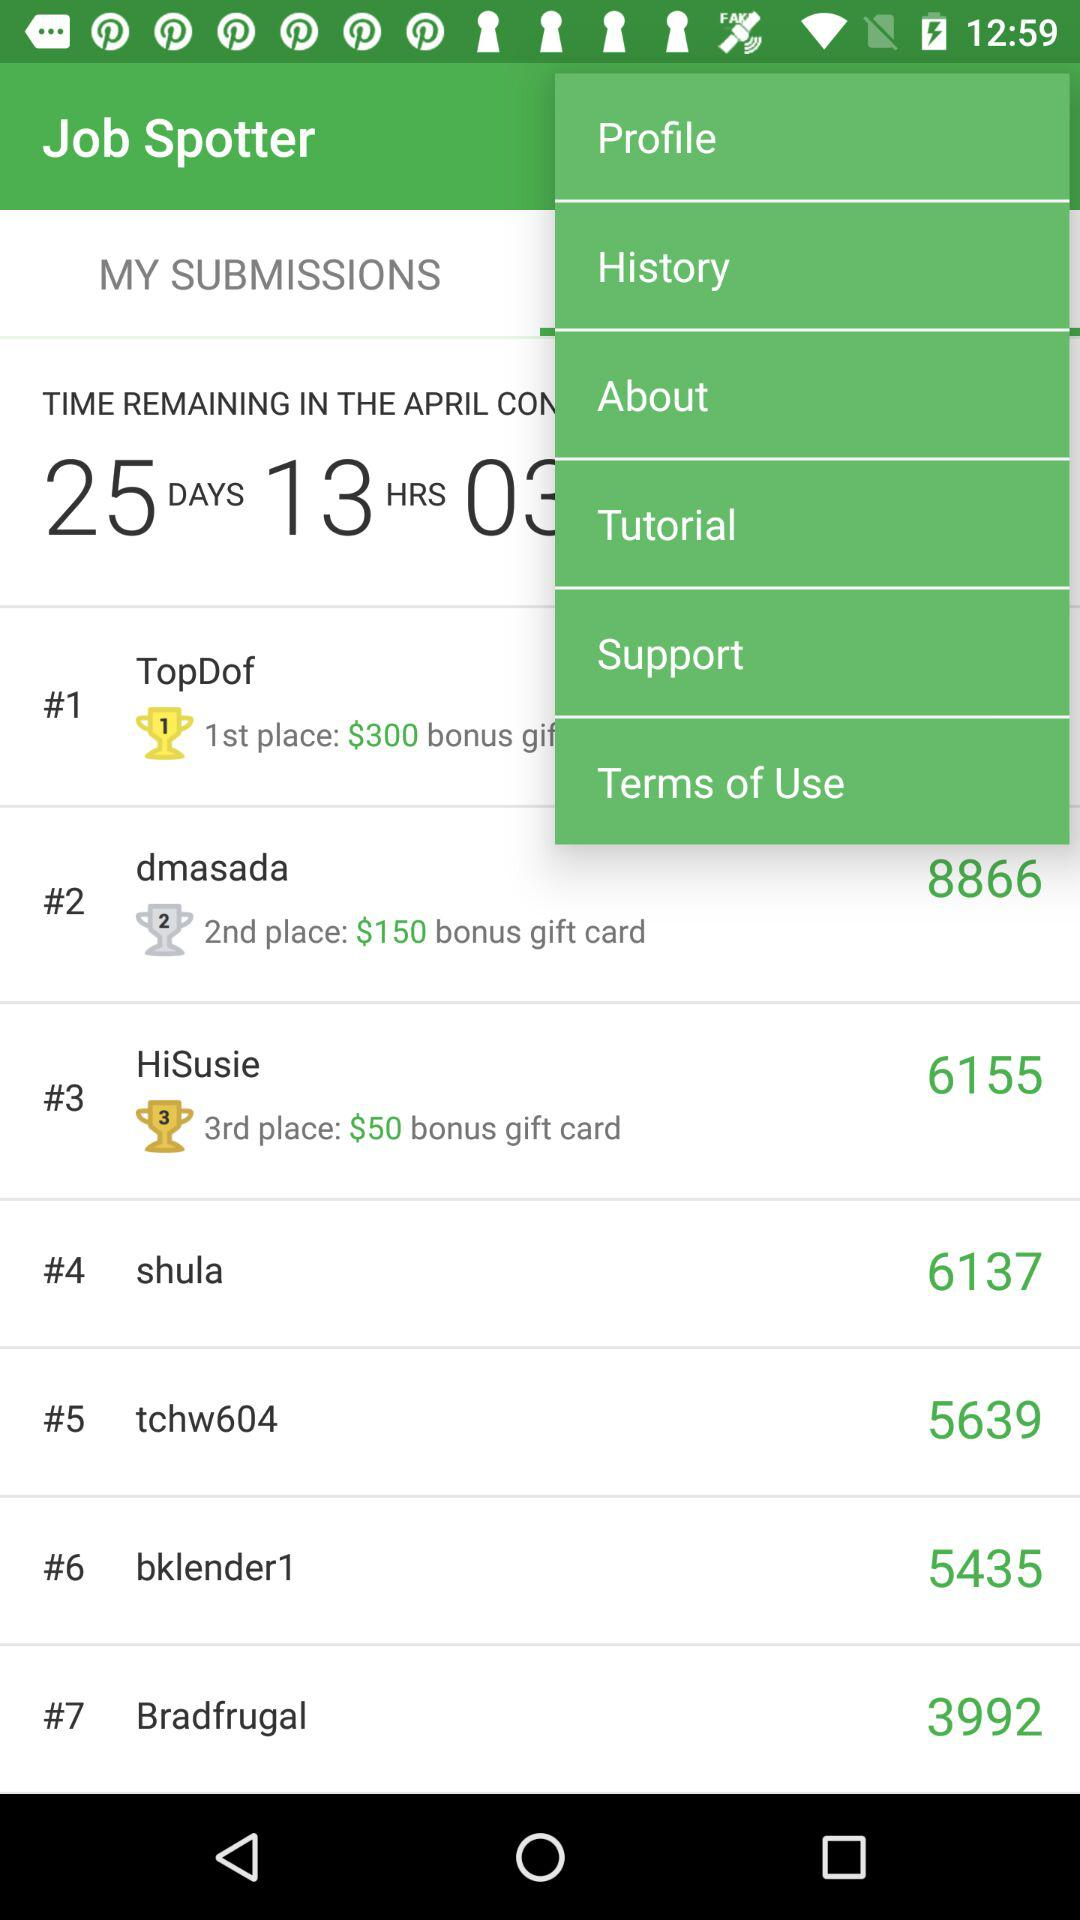How much is the gift bonus in 3rd place? The gift bonus in 3rd place is $50. 